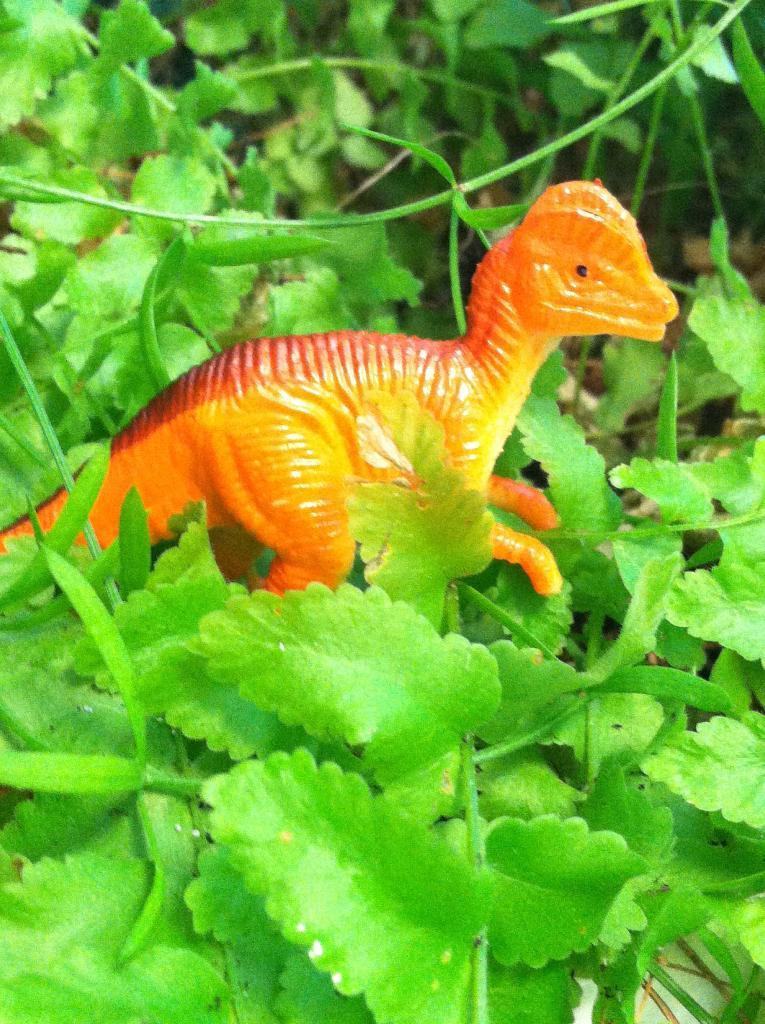What type of toy is present in the image? There is a toy dinosaur in the image. What can be seen in the background of the image? There are plants and grass in the background of the image. What type of yam is being grown in the image? There is no yam present in the image; it features a toy dinosaur and plants in the background. What country is depicted in the image? The image does not depict a specific country; it is a close-up of a toy dinosaur and plants in the background. 